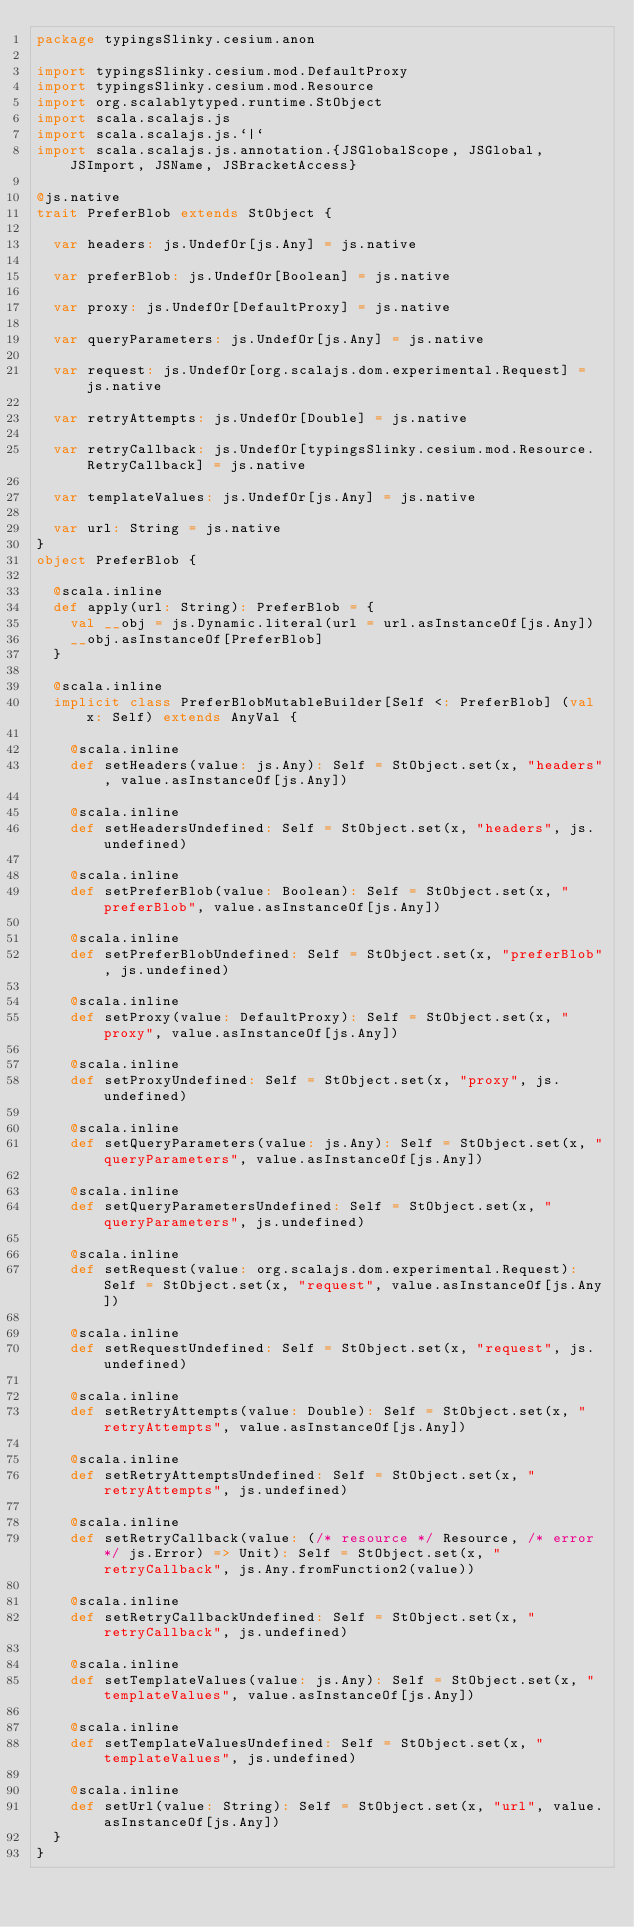<code> <loc_0><loc_0><loc_500><loc_500><_Scala_>package typingsSlinky.cesium.anon

import typingsSlinky.cesium.mod.DefaultProxy
import typingsSlinky.cesium.mod.Resource
import org.scalablytyped.runtime.StObject
import scala.scalajs.js
import scala.scalajs.js.`|`
import scala.scalajs.js.annotation.{JSGlobalScope, JSGlobal, JSImport, JSName, JSBracketAccess}

@js.native
trait PreferBlob extends StObject {
  
  var headers: js.UndefOr[js.Any] = js.native
  
  var preferBlob: js.UndefOr[Boolean] = js.native
  
  var proxy: js.UndefOr[DefaultProxy] = js.native
  
  var queryParameters: js.UndefOr[js.Any] = js.native
  
  var request: js.UndefOr[org.scalajs.dom.experimental.Request] = js.native
  
  var retryAttempts: js.UndefOr[Double] = js.native
  
  var retryCallback: js.UndefOr[typingsSlinky.cesium.mod.Resource.RetryCallback] = js.native
  
  var templateValues: js.UndefOr[js.Any] = js.native
  
  var url: String = js.native
}
object PreferBlob {
  
  @scala.inline
  def apply(url: String): PreferBlob = {
    val __obj = js.Dynamic.literal(url = url.asInstanceOf[js.Any])
    __obj.asInstanceOf[PreferBlob]
  }
  
  @scala.inline
  implicit class PreferBlobMutableBuilder[Self <: PreferBlob] (val x: Self) extends AnyVal {
    
    @scala.inline
    def setHeaders(value: js.Any): Self = StObject.set(x, "headers", value.asInstanceOf[js.Any])
    
    @scala.inline
    def setHeadersUndefined: Self = StObject.set(x, "headers", js.undefined)
    
    @scala.inline
    def setPreferBlob(value: Boolean): Self = StObject.set(x, "preferBlob", value.asInstanceOf[js.Any])
    
    @scala.inline
    def setPreferBlobUndefined: Self = StObject.set(x, "preferBlob", js.undefined)
    
    @scala.inline
    def setProxy(value: DefaultProxy): Self = StObject.set(x, "proxy", value.asInstanceOf[js.Any])
    
    @scala.inline
    def setProxyUndefined: Self = StObject.set(x, "proxy", js.undefined)
    
    @scala.inline
    def setQueryParameters(value: js.Any): Self = StObject.set(x, "queryParameters", value.asInstanceOf[js.Any])
    
    @scala.inline
    def setQueryParametersUndefined: Self = StObject.set(x, "queryParameters", js.undefined)
    
    @scala.inline
    def setRequest(value: org.scalajs.dom.experimental.Request): Self = StObject.set(x, "request", value.asInstanceOf[js.Any])
    
    @scala.inline
    def setRequestUndefined: Self = StObject.set(x, "request", js.undefined)
    
    @scala.inline
    def setRetryAttempts(value: Double): Self = StObject.set(x, "retryAttempts", value.asInstanceOf[js.Any])
    
    @scala.inline
    def setRetryAttemptsUndefined: Self = StObject.set(x, "retryAttempts", js.undefined)
    
    @scala.inline
    def setRetryCallback(value: (/* resource */ Resource, /* error */ js.Error) => Unit): Self = StObject.set(x, "retryCallback", js.Any.fromFunction2(value))
    
    @scala.inline
    def setRetryCallbackUndefined: Self = StObject.set(x, "retryCallback", js.undefined)
    
    @scala.inline
    def setTemplateValues(value: js.Any): Self = StObject.set(x, "templateValues", value.asInstanceOf[js.Any])
    
    @scala.inline
    def setTemplateValuesUndefined: Self = StObject.set(x, "templateValues", js.undefined)
    
    @scala.inline
    def setUrl(value: String): Self = StObject.set(x, "url", value.asInstanceOf[js.Any])
  }
}
</code> 